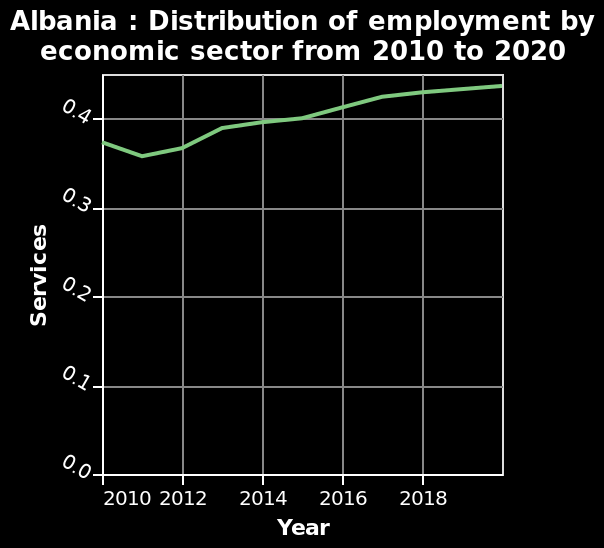<image>
What sector is represented by the line diagram?  The line diagram represents the distribution of employment by economic sector in Albania. In which year did the rate of employment in the service sector decrease?  The rate of employment in the service sector decreased from 2010 to 2011. What was the rate of employment in the service sector in 2010?  The rate of employment in the service sector in 2010 was 0.37. 